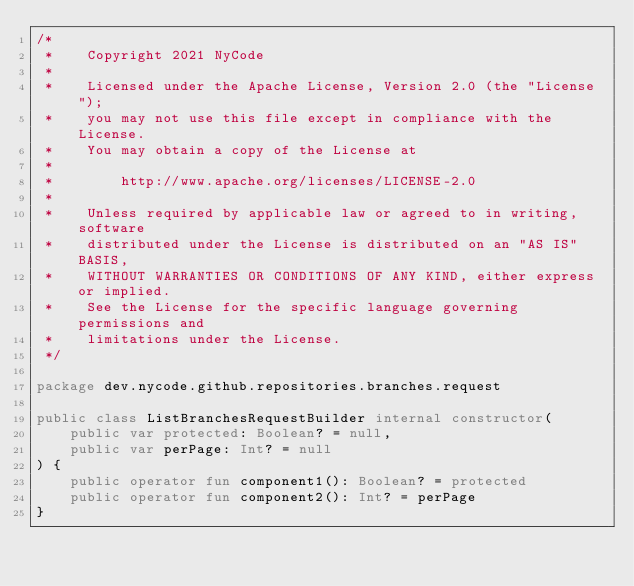<code> <loc_0><loc_0><loc_500><loc_500><_Kotlin_>/*
 *    Copyright 2021 NyCode
 *
 *    Licensed under the Apache License, Version 2.0 (the "License");
 *    you may not use this file except in compliance with the License.
 *    You may obtain a copy of the License at
 *
 *        http://www.apache.org/licenses/LICENSE-2.0
 *
 *    Unless required by applicable law or agreed to in writing, software
 *    distributed under the License is distributed on an "AS IS" BASIS,
 *    WITHOUT WARRANTIES OR CONDITIONS OF ANY KIND, either express or implied.
 *    See the License for the specific language governing permissions and
 *    limitations under the License.
 */

package dev.nycode.github.repositories.branches.request

public class ListBranchesRequestBuilder internal constructor(
    public var protected: Boolean? = null,
    public var perPage: Int? = null
) {
    public operator fun component1(): Boolean? = protected
    public operator fun component2(): Int? = perPage
}
</code> 